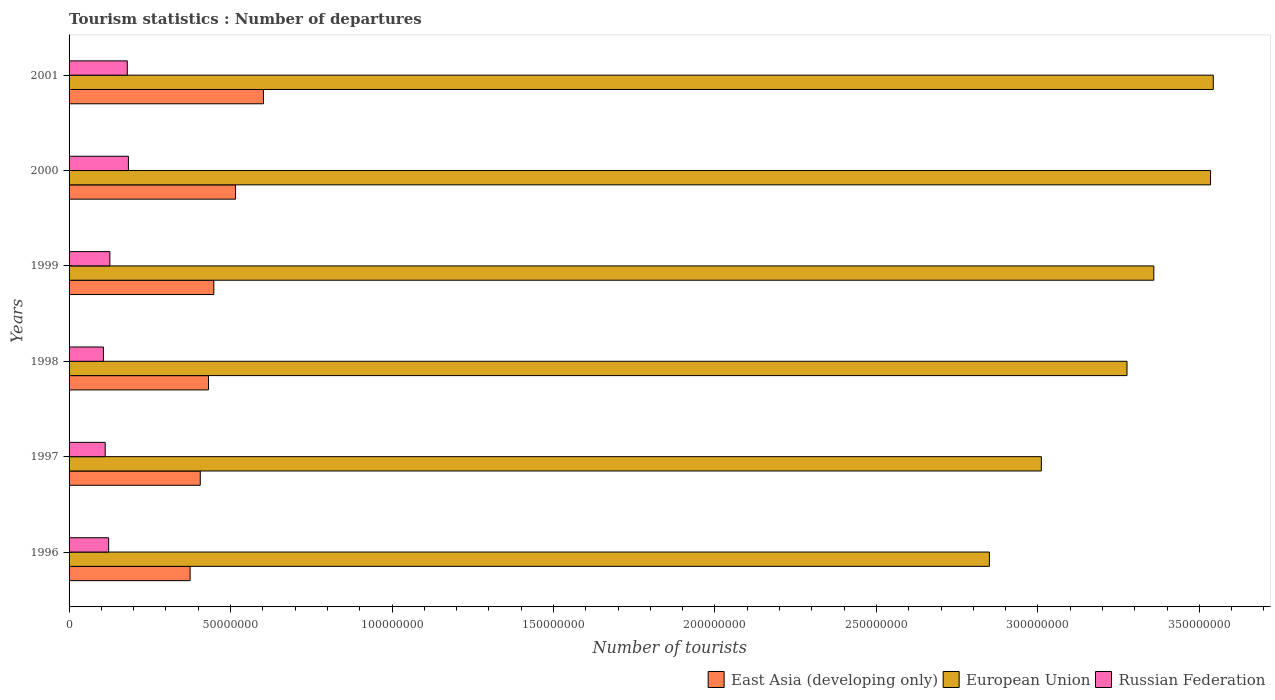How many different coloured bars are there?
Keep it short and to the point. 3. How many groups of bars are there?
Your answer should be very brief. 6. Are the number of bars on each tick of the Y-axis equal?
Give a very brief answer. Yes. What is the label of the 6th group of bars from the top?
Make the answer very short. 1996. In how many cases, is the number of bars for a given year not equal to the number of legend labels?
Offer a terse response. 0. What is the number of tourist departures in European Union in 1999?
Give a very brief answer. 3.36e+08. Across all years, what is the maximum number of tourist departures in East Asia (developing only)?
Your answer should be compact. 6.02e+07. Across all years, what is the minimum number of tourist departures in East Asia (developing only)?
Offer a terse response. 3.75e+07. In which year was the number of tourist departures in East Asia (developing only) minimum?
Offer a terse response. 1996. What is the total number of tourist departures in European Union in the graph?
Your answer should be compact. 1.96e+09. What is the difference between the number of tourist departures in East Asia (developing only) in 1999 and that in 2001?
Provide a short and direct response. -1.54e+07. What is the difference between the number of tourist departures in East Asia (developing only) in 1997 and the number of tourist departures in European Union in 2001?
Provide a succinct answer. -3.14e+08. What is the average number of tourist departures in East Asia (developing only) per year?
Make the answer very short. 4.63e+07. In the year 2000, what is the difference between the number of tourist departures in Russian Federation and number of tourist departures in European Union?
Provide a succinct answer. -3.35e+08. In how many years, is the number of tourist departures in East Asia (developing only) greater than 210000000 ?
Your response must be concise. 0. What is the ratio of the number of tourist departures in Russian Federation in 1998 to that in 2000?
Your answer should be compact. 0.58. What is the difference between the highest and the second highest number of tourist departures in East Asia (developing only)?
Keep it short and to the point. 8.63e+06. What is the difference between the highest and the lowest number of tourist departures in Russian Federation?
Your answer should be compact. 7.74e+06. In how many years, is the number of tourist departures in East Asia (developing only) greater than the average number of tourist departures in East Asia (developing only) taken over all years?
Make the answer very short. 2. Is the sum of the number of tourist departures in European Union in 1996 and 1997 greater than the maximum number of tourist departures in Russian Federation across all years?
Provide a short and direct response. Yes. What does the 3rd bar from the top in 1996 represents?
Keep it short and to the point. East Asia (developing only). What does the 1st bar from the bottom in 1997 represents?
Ensure brevity in your answer.  East Asia (developing only). Are all the bars in the graph horizontal?
Ensure brevity in your answer.  Yes. How many years are there in the graph?
Offer a very short reply. 6. What is the difference between two consecutive major ticks on the X-axis?
Give a very brief answer. 5.00e+07. Does the graph contain any zero values?
Make the answer very short. No. Does the graph contain grids?
Your answer should be compact. No. Where does the legend appear in the graph?
Provide a succinct answer. Bottom right. How many legend labels are there?
Make the answer very short. 3. What is the title of the graph?
Your answer should be very brief. Tourism statistics : Number of departures. What is the label or title of the X-axis?
Provide a short and direct response. Number of tourists. What is the label or title of the Y-axis?
Make the answer very short. Years. What is the Number of tourists of East Asia (developing only) in 1996?
Keep it short and to the point. 3.75e+07. What is the Number of tourists in European Union in 1996?
Provide a short and direct response. 2.85e+08. What is the Number of tourists of Russian Federation in 1996?
Make the answer very short. 1.23e+07. What is the Number of tourists in East Asia (developing only) in 1997?
Provide a short and direct response. 4.06e+07. What is the Number of tourists of European Union in 1997?
Your answer should be very brief. 3.01e+08. What is the Number of tourists of Russian Federation in 1997?
Your answer should be compact. 1.12e+07. What is the Number of tourists in East Asia (developing only) in 1998?
Ensure brevity in your answer.  4.32e+07. What is the Number of tourists in European Union in 1998?
Your answer should be very brief. 3.28e+08. What is the Number of tourists of Russian Federation in 1998?
Provide a short and direct response. 1.06e+07. What is the Number of tourists of East Asia (developing only) in 1999?
Your answer should be very brief. 4.48e+07. What is the Number of tourists in European Union in 1999?
Ensure brevity in your answer.  3.36e+08. What is the Number of tourists of Russian Federation in 1999?
Your answer should be very brief. 1.26e+07. What is the Number of tourists of East Asia (developing only) in 2000?
Your answer should be very brief. 5.16e+07. What is the Number of tourists in European Union in 2000?
Provide a short and direct response. 3.53e+08. What is the Number of tourists of Russian Federation in 2000?
Provide a short and direct response. 1.84e+07. What is the Number of tourists in East Asia (developing only) in 2001?
Give a very brief answer. 6.02e+07. What is the Number of tourists in European Union in 2001?
Your answer should be very brief. 3.54e+08. What is the Number of tourists in Russian Federation in 2001?
Provide a succinct answer. 1.80e+07. Across all years, what is the maximum Number of tourists of East Asia (developing only)?
Ensure brevity in your answer.  6.02e+07. Across all years, what is the maximum Number of tourists of European Union?
Offer a very short reply. 3.54e+08. Across all years, what is the maximum Number of tourists of Russian Federation?
Provide a short and direct response. 1.84e+07. Across all years, what is the minimum Number of tourists in East Asia (developing only)?
Provide a succinct answer. 3.75e+07. Across all years, what is the minimum Number of tourists of European Union?
Provide a short and direct response. 2.85e+08. Across all years, what is the minimum Number of tourists in Russian Federation?
Your response must be concise. 1.06e+07. What is the total Number of tourists in East Asia (developing only) in the graph?
Your answer should be very brief. 2.78e+08. What is the total Number of tourists in European Union in the graph?
Offer a very short reply. 1.96e+09. What is the total Number of tourists in Russian Federation in the graph?
Provide a short and direct response. 8.31e+07. What is the difference between the Number of tourists of East Asia (developing only) in 1996 and that in 1997?
Your answer should be compact. -3.15e+06. What is the difference between the Number of tourists in European Union in 1996 and that in 1997?
Offer a very short reply. -1.61e+07. What is the difference between the Number of tourists in Russian Federation in 1996 and that in 1997?
Your answer should be very brief. 1.08e+06. What is the difference between the Number of tourists of East Asia (developing only) in 1996 and that in 1998?
Your answer should be compact. -5.69e+06. What is the difference between the Number of tourists in European Union in 1996 and that in 1998?
Your answer should be compact. -4.26e+07. What is the difference between the Number of tourists in Russian Federation in 1996 and that in 1998?
Keep it short and to the point. 1.62e+06. What is the difference between the Number of tourists of East Asia (developing only) in 1996 and that in 1999?
Your answer should be compact. -7.34e+06. What is the difference between the Number of tourists in European Union in 1996 and that in 1999?
Provide a succinct answer. -5.09e+07. What is the difference between the Number of tourists of Russian Federation in 1996 and that in 1999?
Offer a terse response. -3.71e+05. What is the difference between the Number of tourists of East Asia (developing only) in 1996 and that in 2000?
Provide a short and direct response. -1.41e+07. What is the difference between the Number of tourists of European Union in 1996 and that in 2000?
Ensure brevity in your answer.  -6.85e+07. What is the difference between the Number of tourists of Russian Federation in 1996 and that in 2000?
Provide a short and direct response. -6.11e+06. What is the difference between the Number of tourists of East Asia (developing only) in 1996 and that in 2001?
Make the answer very short. -2.27e+07. What is the difference between the Number of tourists in European Union in 1996 and that in 2001?
Your response must be concise. -6.93e+07. What is the difference between the Number of tourists in Russian Federation in 1996 and that in 2001?
Keep it short and to the point. -5.77e+06. What is the difference between the Number of tourists in East Asia (developing only) in 1997 and that in 1998?
Offer a terse response. -2.54e+06. What is the difference between the Number of tourists of European Union in 1997 and that in 1998?
Offer a terse response. -2.65e+07. What is the difference between the Number of tourists of Russian Federation in 1997 and that in 1998?
Your answer should be compact. 5.47e+05. What is the difference between the Number of tourists in East Asia (developing only) in 1997 and that in 1999?
Give a very brief answer. -4.20e+06. What is the difference between the Number of tourists of European Union in 1997 and that in 1999?
Your answer should be compact. -3.48e+07. What is the difference between the Number of tourists of Russian Federation in 1997 and that in 1999?
Provide a short and direct response. -1.45e+06. What is the difference between the Number of tourists of East Asia (developing only) in 1997 and that in 2000?
Your response must be concise. -1.09e+07. What is the difference between the Number of tourists in European Union in 1997 and that in 2000?
Offer a very short reply. -5.24e+07. What is the difference between the Number of tourists in Russian Federation in 1997 and that in 2000?
Make the answer very short. -7.19e+06. What is the difference between the Number of tourists in East Asia (developing only) in 1997 and that in 2001?
Make the answer very short. -1.96e+07. What is the difference between the Number of tourists of European Union in 1997 and that in 2001?
Offer a terse response. -5.32e+07. What is the difference between the Number of tourists in Russian Federation in 1997 and that in 2001?
Keep it short and to the point. -6.85e+06. What is the difference between the Number of tourists of East Asia (developing only) in 1998 and that in 1999?
Give a very brief answer. -1.65e+06. What is the difference between the Number of tourists in European Union in 1998 and that in 1999?
Keep it short and to the point. -8.30e+06. What is the difference between the Number of tourists in Russian Federation in 1998 and that in 1999?
Your answer should be compact. -2.00e+06. What is the difference between the Number of tourists of East Asia (developing only) in 1998 and that in 2000?
Provide a short and direct response. -8.39e+06. What is the difference between the Number of tourists of European Union in 1998 and that in 2000?
Provide a succinct answer. -2.59e+07. What is the difference between the Number of tourists in Russian Federation in 1998 and that in 2000?
Your response must be concise. -7.74e+06. What is the difference between the Number of tourists in East Asia (developing only) in 1998 and that in 2001?
Offer a very short reply. -1.70e+07. What is the difference between the Number of tourists of European Union in 1998 and that in 2001?
Your answer should be compact. -2.67e+07. What is the difference between the Number of tourists of Russian Federation in 1998 and that in 2001?
Keep it short and to the point. -7.40e+06. What is the difference between the Number of tourists of East Asia (developing only) in 1999 and that in 2000?
Your answer should be compact. -6.74e+06. What is the difference between the Number of tourists of European Union in 1999 and that in 2000?
Give a very brief answer. -1.76e+07. What is the difference between the Number of tourists in Russian Federation in 1999 and that in 2000?
Provide a short and direct response. -5.74e+06. What is the difference between the Number of tourists in East Asia (developing only) in 1999 and that in 2001?
Keep it short and to the point. -1.54e+07. What is the difference between the Number of tourists of European Union in 1999 and that in 2001?
Provide a succinct answer. -1.84e+07. What is the difference between the Number of tourists in Russian Federation in 1999 and that in 2001?
Ensure brevity in your answer.  -5.40e+06. What is the difference between the Number of tourists in East Asia (developing only) in 2000 and that in 2001?
Provide a succinct answer. -8.63e+06. What is the difference between the Number of tourists in European Union in 2000 and that in 2001?
Give a very brief answer. -8.54e+05. What is the difference between the Number of tourists of Russian Federation in 2000 and that in 2001?
Make the answer very short. 3.41e+05. What is the difference between the Number of tourists of East Asia (developing only) in 1996 and the Number of tourists of European Union in 1997?
Your answer should be compact. -2.64e+08. What is the difference between the Number of tourists in East Asia (developing only) in 1996 and the Number of tourists in Russian Federation in 1997?
Provide a short and direct response. 2.63e+07. What is the difference between the Number of tourists in European Union in 1996 and the Number of tourists in Russian Federation in 1997?
Your answer should be very brief. 2.74e+08. What is the difference between the Number of tourists of East Asia (developing only) in 1996 and the Number of tourists of European Union in 1998?
Provide a short and direct response. -2.90e+08. What is the difference between the Number of tourists of East Asia (developing only) in 1996 and the Number of tourists of Russian Federation in 1998?
Provide a short and direct response. 2.68e+07. What is the difference between the Number of tourists in European Union in 1996 and the Number of tourists in Russian Federation in 1998?
Your response must be concise. 2.74e+08. What is the difference between the Number of tourists of East Asia (developing only) in 1996 and the Number of tourists of European Union in 1999?
Ensure brevity in your answer.  -2.98e+08. What is the difference between the Number of tourists of East Asia (developing only) in 1996 and the Number of tourists of Russian Federation in 1999?
Keep it short and to the point. 2.48e+07. What is the difference between the Number of tourists of European Union in 1996 and the Number of tourists of Russian Federation in 1999?
Offer a very short reply. 2.72e+08. What is the difference between the Number of tourists in East Asia (developing only) in 1996 and the Number of tourists in European Union in 2000?
Your response must be concise. -3.16e+08. What is the difference between the Number of tourists in East Asia (developing only) in 1996 and the Number of tourists in Russian Federation in 2000?
Offer a very short reply. 1.91e+07. What is the difference between the Number of tourists in European Union in 1996 and the Number of tourists in Russian Federation in 2000?
Offer a very short reply. 2.67e+08. What is the difference between the Number of tourists of East Asia (developing only) in 1996 and the Number of tourists of European Union in 2001?
Keep it short and to the point. -3.17e+08. What is the difference between the Number of tourists of East Asia (developing only) in 1996 and the Number of tourists of Russian Federation in 2001?
Provide a short and direct response. 1.94e+07. What is the difference between the Number of tourists of European Union in 1996 and the Number of tourists of Russian Federation in 2001?
Give a very brief answer. 2.67e+08. What is the difference between the Number of tourists in East Asia (developing only) in 1997 and the Number of tourists in European Union in 1998?
Give a very brief answer. -2.87e+08. What is the difference between the Number of tourists in East Asia (developing only) in 1997 and the Number of tourists in Russian Federation in 1998?
Keep it short and to the point. 3.00e+07. What is the difference between the Number of tourists in European Union in 1997 and the Number of tourists in Russian Federation in 1998?
Give a very brief answer. 2.90e+08. What is the difference between the Number of tourists in East Asia (developing only) in 1997 and the Number of tourists in European Union in 1999?
Offer a terse response. -2.95e+08. What is the difference between the Number of tourists in East Asia (developing only) in 1997 and the Number of tourists in Russian Federation in 1999?
Provide a short and direct response. 2.80e+07. What is the difference between the Number of tourists of European Union in 1997 and the Number of tourists of Russian Federation in 1999?
Your response must be concise. 2.88e+08. What is the difference between the Number of tourists of East Asia (developing only) in 1997 and the Number of tourists of European Union in 2000?
Make the answer very short. -3.13e+08. What is the difference between the Number of tourists of East Asia (developing only) in 1997 and the Number of tourists of Russian Federation in 2000?
Provide a short and direct response. 2.23e+07. What is the difference between the Number of tourists of European Union in 1997 and the Number of tourists of Russian Federation in 2000?
Offer a terse response. 2.83e+08. What is the difference between the Number of tourists of East Asia (developing only) in 1997 and the Number of tourists of European Union in 2001?
Make the answer very short. -3.14e+08. What is the difference between the Number of tourists in East Asia (developing only) in 1997 and the Number of tourists in Russian Federation in 2001?
Give a very brief answer. 2.26e+07. What is the difference between the Number of tourists of European Union in 1997 and the Number of tourists of Russian Federation in 2001?
Your answer should be compact. 2.83e+08. What is the difference between the Number of tourists in East Asia (developing only) in 1998 and the Number of tourists in European Union in 1999?
Your answer should be very brief. -2.93e+08. What is the difference between the Number of tourists of East Asia (developing only) in 1998 and the Number of tourists of Russian Federation in 1999?
Provide a short and direct response. 3.05e+07. What is the difference between the Number of tourists of European Union in 1998 and the Number of tourists of Russian Federation in 1999?
Keep it short and to the point. 3.15e+08. What is the difference between the Number of tourists of East Asia (developing only) in 1998 and the Number of tourists of European Union in 2000?
Provide a succinct answer. -3.10e+08. What is the difference between the Number of tourists in East Asia (developing only) in 1998 and the Number of tourists in Russian Federation in 2000?
Provide a short and direct response. 2.48e+07. What is the difference between the Number of tourists of European Union in 1998 and the Number of tourists of Russian Federation in 2000?
Give a very brief answer. 3.09e+08. What is the difference between the Number of tourists in East Asia (developing only) in 1998 and the Number of tourists in European Union in 2001?
Your answer should be compact. -3.11e+08. What is the difference between the Number of tourists in East Asia (developing only) in 1998 and the Number of tourists in Russian Federation in 2001?
Ensure brevity in your answer.  2.51e+07. What is the difference between the Number of tourists in European Union in 1998 and the Number of tourists in Russian Federation in 2001?
Offer a very short reply. 3.10e+08. What is the difference between the Number of tourists in East Asia (developing only) in 1999 and the Number of tourists in European Union in 2000?
Ensure brevity in your answer.  -3.09e+08. What is the difference between the Number of tourists of East Asia (developing only) in 1999 and the Number of tourists of Russian Federation in 2000?
Your response must be concise. 2.64e+07. What is the difference between the Number of tourists in European Union in 1999 and the Number of tourists in Russian Federation in 2000?
Provide a succinct answer. 3.18e+08. What is the difference between the Number of tourists in East Asia (developing only) in 1999 and the Number of tourists in European Union in 2001?
Offer a very short reply. -3.09e+08. What is the difference between the Number of tourists in East Asia (developing only) in 1999 and the Number of tourists in Russian Federation in 2001?
Make the answer very short. 2.68e+07. What is the difference between the Number of tourists of European Union in 1999 and the Number of tourists of Russian Federation in 2001?
Provide a short and direct response. 3.18e+08. What is the difference between the Number of tourists in East Asia (developing only) in 2000 and the Number of tourists in European Union in 2001?
Your response must be concise. -3.03e+08. What is the difference between the Number of tourists of East Asia (developing only) in 2000 and the Number of tourists of Russian Federation in 2001?
Your response must be concise. 3.35e+07. What is the difference between the Number of tourists of European Union in 2000 and the Number of tourists of Russian Federation in 2001?
Keep it short and to the point. 3.35e+08. What is the average Number of tourists of East Asia (developing only) per year?
Your answer should be very brief. 4.63e+07. What is the average Number of tourists in European Union per year?
Keep it short and to the point. 3.26e+08. What is the average Number of tourists of Russian Federation per year?
Provide a short and direct response. 1.39e+07. In the year 1996, what is the difference between the Number of tourists of East Asia (developing only) and Number of tourists of European Union?
Offer a very short reply. -2.48e+08. In the year 1996, what is the difference between the Number of tourists in East Asia (developing only) and Number of tourists in Russian Federation?
Ensure brevity in your answer.  2.52e+07. In the year 1996, what is the difference between the Number of tourists in European Union and Number of tourists in Russian Federation?
Offer a very short reply. 2.73e+08. In the year 1997, what is the difference between the Number of tourists of East Asia (developing only) and Number of tourists of European Union?
Make the answer very short. -2.60e+08. In the year 1997, what is the difference between the Number of tourists of East Asia (developing only) and Number of tourists of Russian Federation?
Keep it short and to the point. 2.94e+07. In the year 1997, what is the difference between the Number of tourists in European Union and Number of tourists in Russian Federation?
Provide a succinct answer. 2.90e+08. In the year 1998, what is the difference between the Number of tourists in East Asia (developing only) and Number of tourists in European Union?
Your answer should be very brief. -2.84e+08. In the year 1998, what is the difference between the Number of tourists of East Asia (developing only) and Number of tourists of Russian Federation?
Your answer should be very brief. 3.25e+07. In the year 1998, what is the difference between the Number of tourists of European Union and Number of tourists of Russian Federation?
Your response must be concise. 3.17e+08. In the year 1999, what is the difference between the Number of tourists of East Asia (developing only) and Number of tourists of European Union?
Keep it short and to the point. -2.91e+08. In the year 1999, what is the difference between the Number of tourists in East Asia (developing only) and Number of tourists in Russian Federation?
Make the answer very short. 3.22e+07. In the year 1999, what is the difference between the Number of tourists in European Union and Number of tourists in Russian Federation?
Provide a short and direct response. 3.23e+08. In the year 2000, what is the difference between the Number of tourists in East Asia (developing only) and Number of tourists in European Union?
Give a very brief answer. -3.02e+08. In the year 2000, what is the difference between the Number of tourists in East Asia (developing only) and Number of tourists in Russian Federation?
Offer a terse response. 3.32e+07. In the year 2000, what is the difference between the Number of tourists of European Union and Number of tourists of Russian Federation?
Provide a short and direct response. 3.35e+08. In the year 2001, what is the difference between the Number of tourists of East Asia (developing only) and Number of tourists of European Union?
Your answer should be compact. -2.94e+08. In the year 2001, what is the difference between the Number of tourists in East Asia (developing only) and Number of tourists in Russian Federation?
Keep it short and to the point. 4.22e+07. In the year 2001, what is the difference between the Number of tourists in European Union and Number of tourists in Russian Federation?
Offer a terse response. 3.36e+08. What is the ratio of the Number of tourists in East Asia (developing only) in 1996 to that in 1997?
Provide a short and direct response. 0.92. What is the ratio of the Number of tourists in European Union in 1996 to that in 1997?
Make the answer very short. 0.95. What is the ratio of the Number of tourists in Russian Federation in 1996 to that in 1997?
Your response must be concise. 1.1. What is the ratio of the Number of tourists in East Asia (developing only) in 1996 to that in 1998?
Provide a short and direct response. 0.87. What is the ratio of the Number of tourists in European Union in 1996 to that in 1998?
Provide a succinct answer. 0.87. What is the ratio of the Number of tourists in Russian Federation in 1996 to that in 1998?
Make the answer very short. 1.15. What is the ratio of the Number of tourists in East Asia (developing only) in 1996 to that in 1999?
Provide a short and direct response. 0.84. What is the ratio of the Number of tourists of European Union in 1996 to that in 1999?
Your answer should be very brief. 0.85. What is the ratio of the Number of tourists in Russian Federation in 1996 to that in 1999?
Keep it short and to the point. 0.97. What is the ratio of the Number of tourists of East Asia (developing only) in 1996 to that in 2000?
Ensure brevity in your answer.  0.73. What is the ratio of the Number of tourists in European Union in 1996 to that in 2000?
Your response must be concise. 0.81. What is the ratio of the Number of tourists of Russian Federation in 1996 to that in 2000?
Make the answer very short. 0.67. What is the ratio of the Number of tourists in East Asia (developing only) in 1996 to that in 2001?
Give a very brief answer. 0.62. What is the ratio of the Number of tourists in European Union in 1996 to that in 2001?
Offer a terse response. 0.8. What is the ratio of the Number of tourists in Russian Federation in 1996 to that in 2001?
Provide a short and direct response. 0.68. What is the ratio of the Number of tourists of East Asia (developing only) in 1997 to that in 1998?
Provide a short and direct response. 0.94. What is the ratio of the Number of tourists in European Union in 1997 to that in 1998?
Offer a terse response. 0.92. What is the ratio of the Number of tourists in Russian Federation in 1997 to that in 1998?
Your answer should be very brief. 1.05. What is the ratio of the Number of tourists of East Asia (developing only) in 1997 to that in 1999?
Your answer should be very brief. 0.91. What is the ratio of the Number of tourists of European Union in 1997 to that in 1999?
Offer a very short reply. 0.9. What is the ratio of the Number of tourists in Russian Federation in 1997 to that in 1999?
Give a very brief answer. 0.89. What is the ratio of the Number of tourists of East Asia (developing only) in 1997 to that in 2000?
Your answer should be compact. 0.79. What is the ratio of the Number of tourists of European Union in 1997 to that in 2000?
Your answer should be very brief. 0.85. What is the ratio of the Number of tourists of Russian Federation in 1997 to that in 2000?
Offer a very short reply. 0.61. What is the ratio of the Number of tourists in East Asia (developing only) in 1997 to that in 2001?
Your answer should be very brief. 0.68. What is the ratio of the Number of tourists of European Union in 1997 to that in 2001?
Give a very brief answer. 0.85. What is the ratio of the Number of tourists of Russian Federation in 1997 to that in 2001?
Ensure brevity in your answer.  0.62. What is the ratio of the Number of tourists in East Asia (developing only) in 1998 to that in 1999?
Ensure brevity in your answer.  0.96. What is the ratio of the Number of tourists of European Union in 1998 to that in 1999?
Your answer should be compact. 0.98. What is the ratio of the Number of tourists of Russian Federation in 1998 to that in 1999?
Your answer should be very brief. 0.84. What is the ratio of the Number of tourists of East Asia (developing only) in 1998 to that in 2000?
Your answer should be very brief. 0.84. What is the ratio of the Number of tourists in European Union in 1998 to that in 2000?
Give a very brief answer. 0.93. What is the ratio of the Number of tourists of Russian Federation in 1998 to that in 2000?
Ensure brevity in your answer.  0.58. What is the ratio of the Number of tourists of East Asia (developing only) in 1998 to that in 2001?
Give a very brief answer. 0.72. What is the ratio of the Number of tourists of European Union in 1998 to that in 2001?
Make the answer very short. 0.92. What is the ratio of the Number of tourists of Russian Federation in 1998 to that in 2001?
Your response must be concise. 0.59. What is the ratio of the Number of tourists in East Asia (developing only) in 1999 to that in 2000?
Offer a very short reply. 0.87. What is the ratio of the Number of tourists in European Union in 1999 to that in 2000?
Provide a short and direct response. 0.95. What is the ratio of the Number of tourists of Russian Federation in 1999 to that in 2000?
Offer a very short reply. 0.69. What is the ratio of the Number of tourists of East Asia (developing only) in 1999 to that in 2001?
Offer a very short reply. 0.74. What is the ratio of the Number of tourists of European Union in 1999 to that in 2001?
Provide a short and direct response. 0.95. What is the ratio of the Number of tourists in Russian Federation in 1999 to that in 2001?
Offer a very short reply. 0.7. What is the ratio of the Number of tourists in East Asia (developing only) in 2000 to that in 2001?
Your response must be concise. 0.86. What is the ratio of the Number of tourists of Russian Federation in 2000 to that in 2001?
Keep it short and to the point. 1.02. What is the difference between the highest and the second highest Number of tourists in East Asia (developing only)?
Offer a terse response. 8.63e+06. What is the difference between the highest and the second highest Number of tourists of European Union?
Provide a succinct answer. 8.54e+05. What is the difference between the highest and the second highest Number of tourists in Russian Federation?
Ensure brevity in your answer.  3.41e+05. What is the difference between the highest and the lowest Number of tourists in East Asia (developing only)?
Give a very brief answer. 2.27e+07. What is the difference between the highest and the lowest Number of tourists of European Union?
Ensure brevity in your answer.  6.93e+07. What is the difference between the highest and the lowest Number of tourists of Russian Federation?
Your answer should be compact. 7.74e+06. 